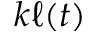<formula> <loc_0><loc_0><loc_500><loc_500>k \ell ( t )</formula> 